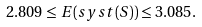<formula> <loc_0><loc_0><loc_500><loc_500>2 . 8 0 9 \leq E ( s y s t ( S ) ) \leq 3 . 0 8 5 .</formula> 